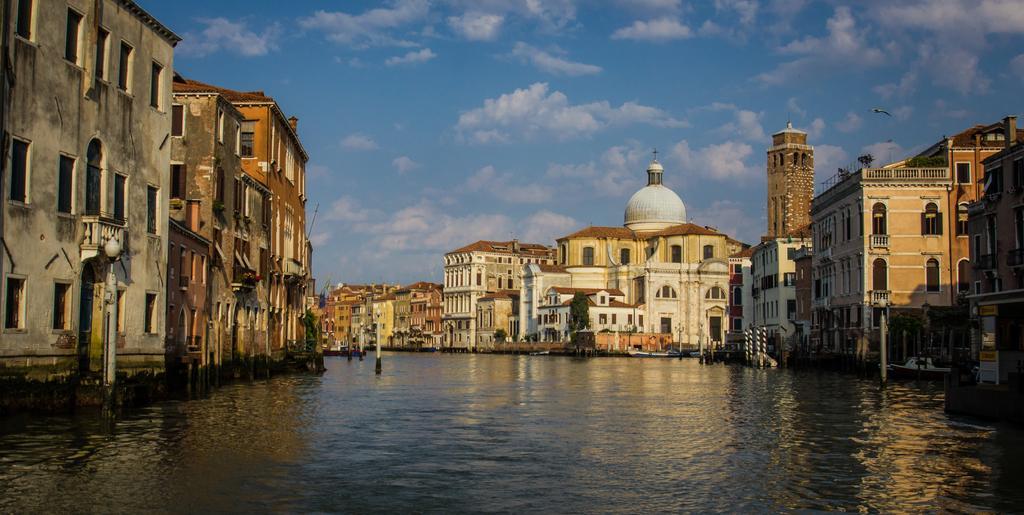How would you summarize this image in a sentence or two? In this picture I can see the water in the center and I can see few light poles. On the both sides of this image I can see the buildings. On the top of this picture I can see the sky and a bird on the top right of this picture. 